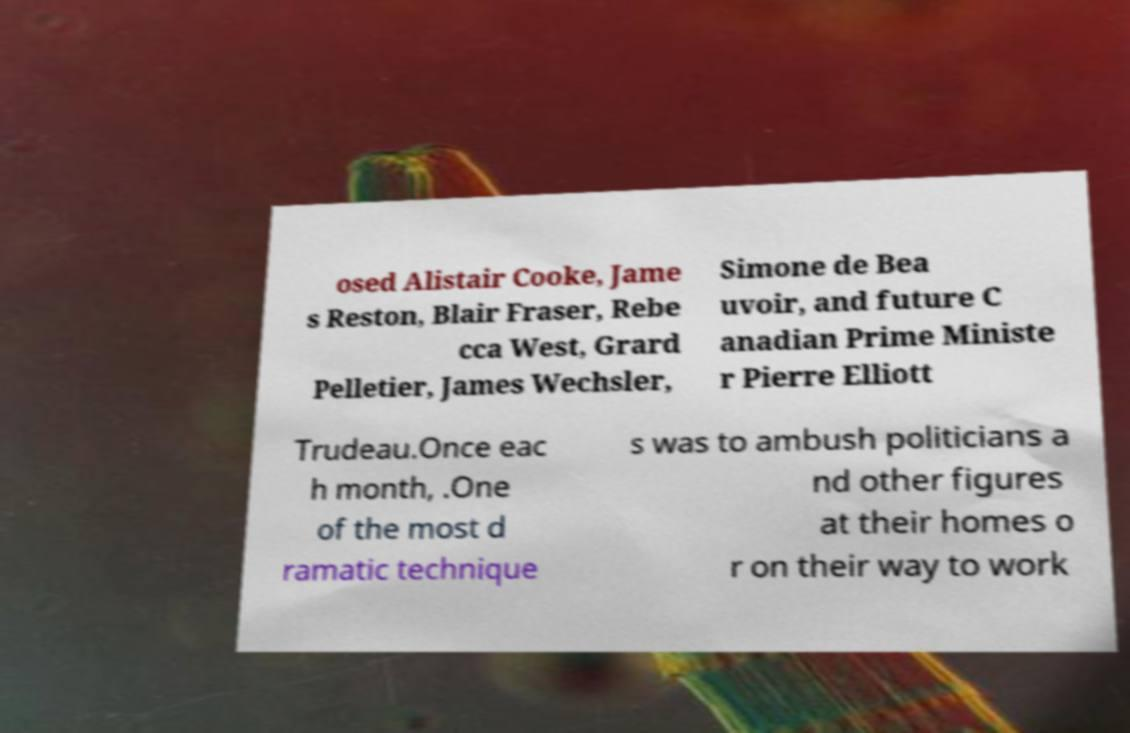What messages or text are displayed in this image? I need them in a readable, typed format. osed Alistair Cooke, Jame s Reston, Blair Fraser, Rebe cca West, Grard Pelletier, James Wechsler, Simone de Bea uvoir, and future C anadian Prime Ministe r Pierre Elliott Trudeau.Once eac h month, .One of the most d ramatic technique s was to ambush politicians a nd other figures at their homes o r on their way to work 